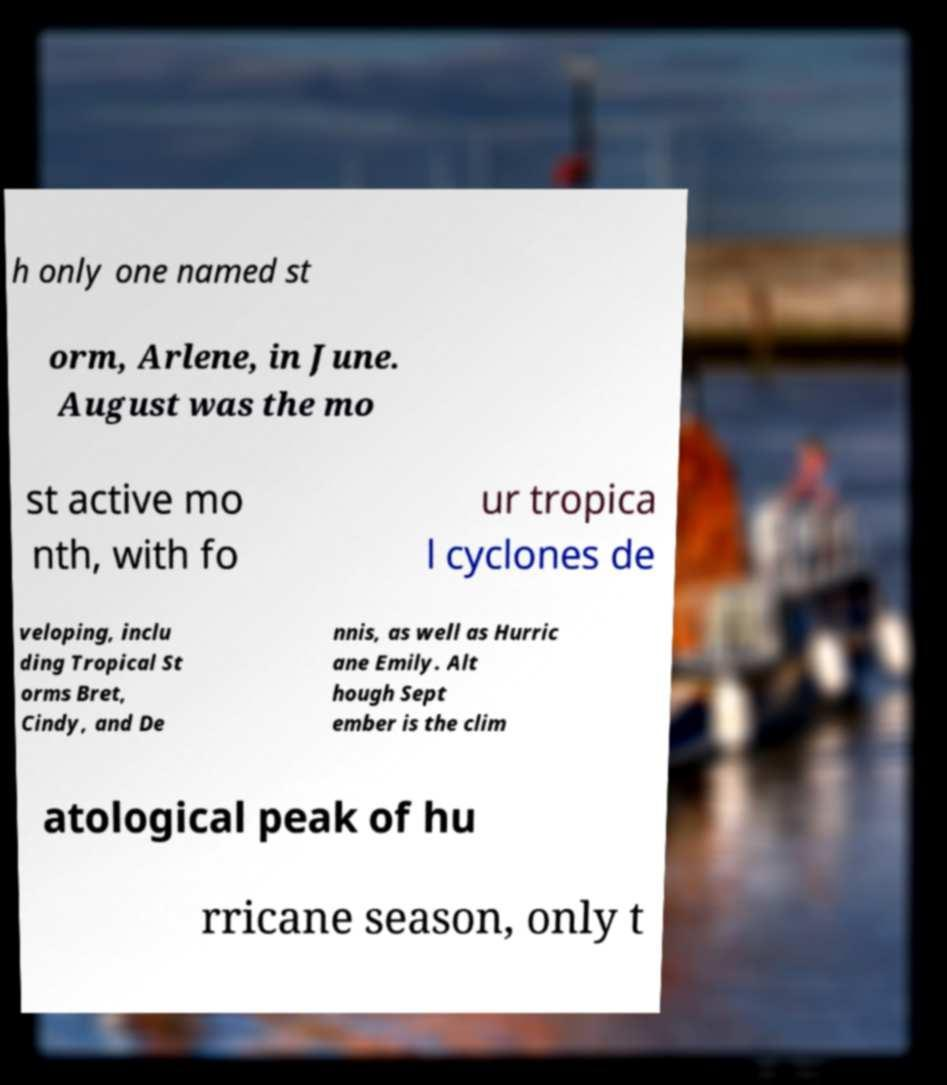I need the written content from this picture converted into text. Can you do that? h only one named st orm, Arlene, in June. August was the mo st active mo nth, with fo ur tropica l cyclones de veloping, inclu ding Tropical St orms Bret, Cindy, and De nnis, as well as Hurric ane Emily. Alt hough Sept ember is the clim atological peak of hu rricane season, only t 